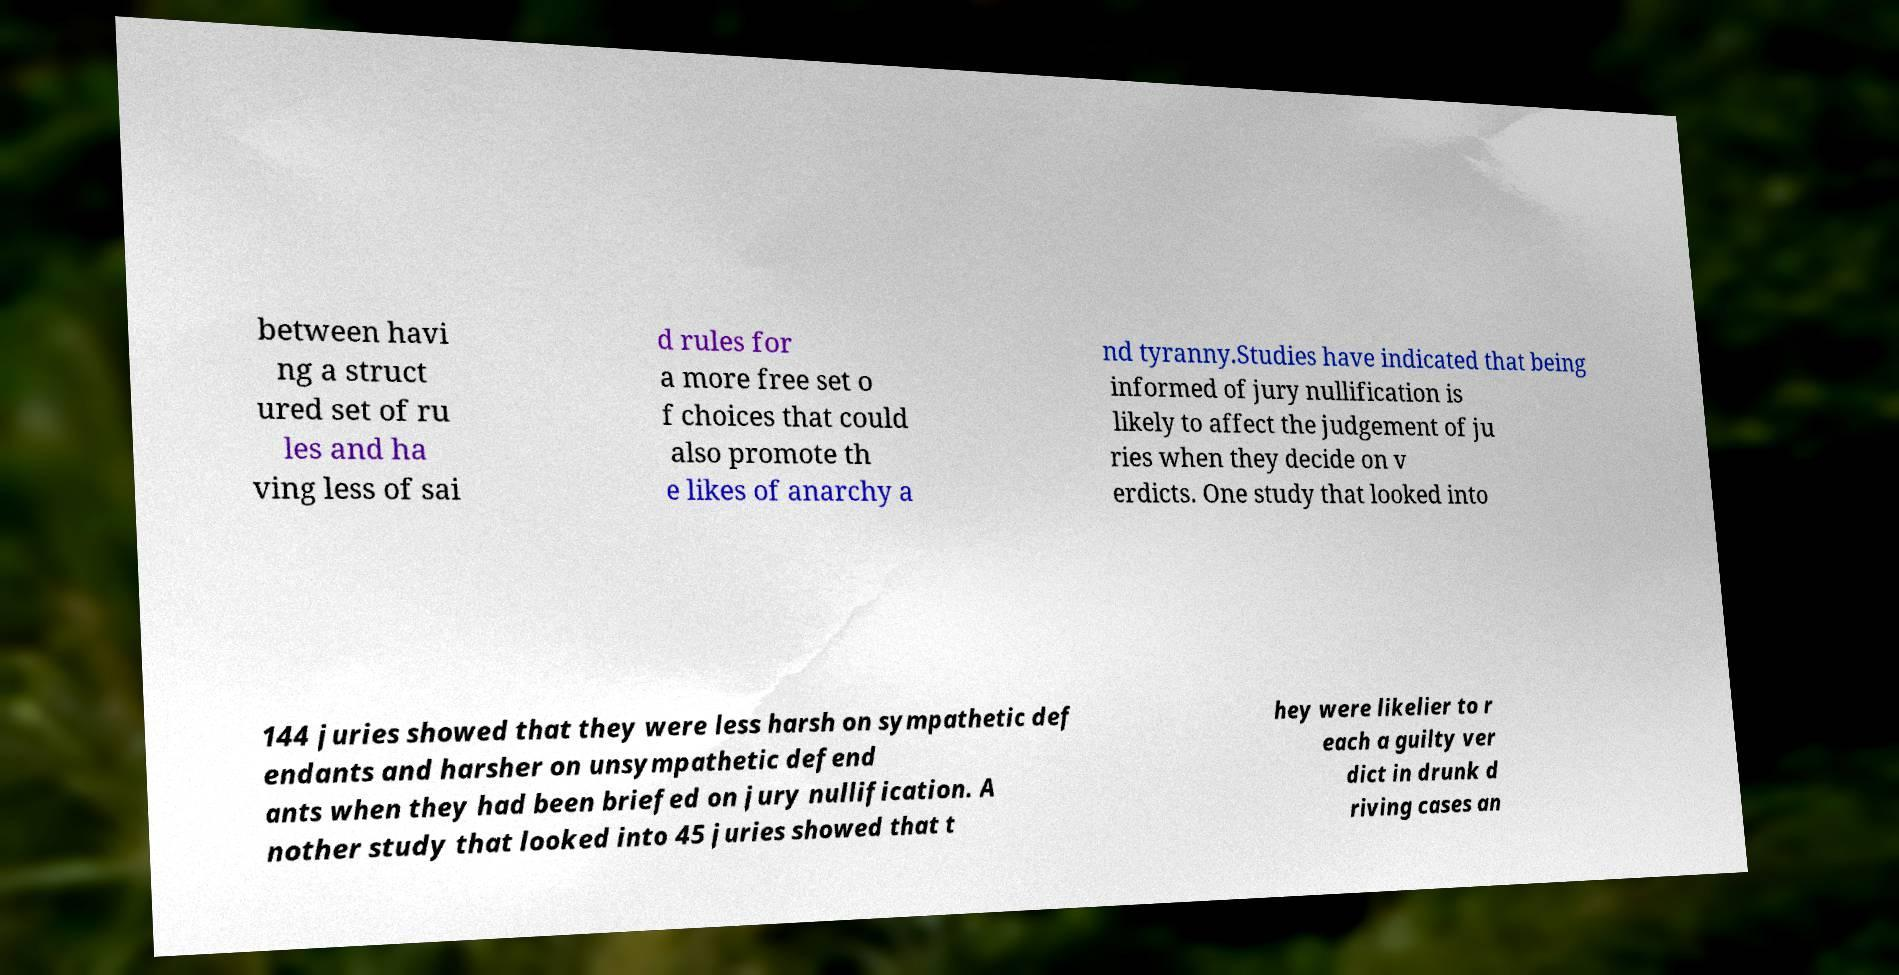Can you accurately transcribe the text from the provided image for me? between havi ng a struct ured set of ru les and ha ving less of sai d rules for a more free set o f choices that could also promote th e likes of anarchy a nd tyranny.Studies have indicated that being informed of jury nullification is likely to affect the judgement of ju ries when they decide on v erdicts. One study that looked into 144 juries showed that they were less harsh on sympathetic def endants and harsher on unsympathetic defend ants when they had been briefed on jury nullification. A nother study that looked into 45 juries showed that t hey were likelier to r each a guilty ver dict in drunk d riving cases an 